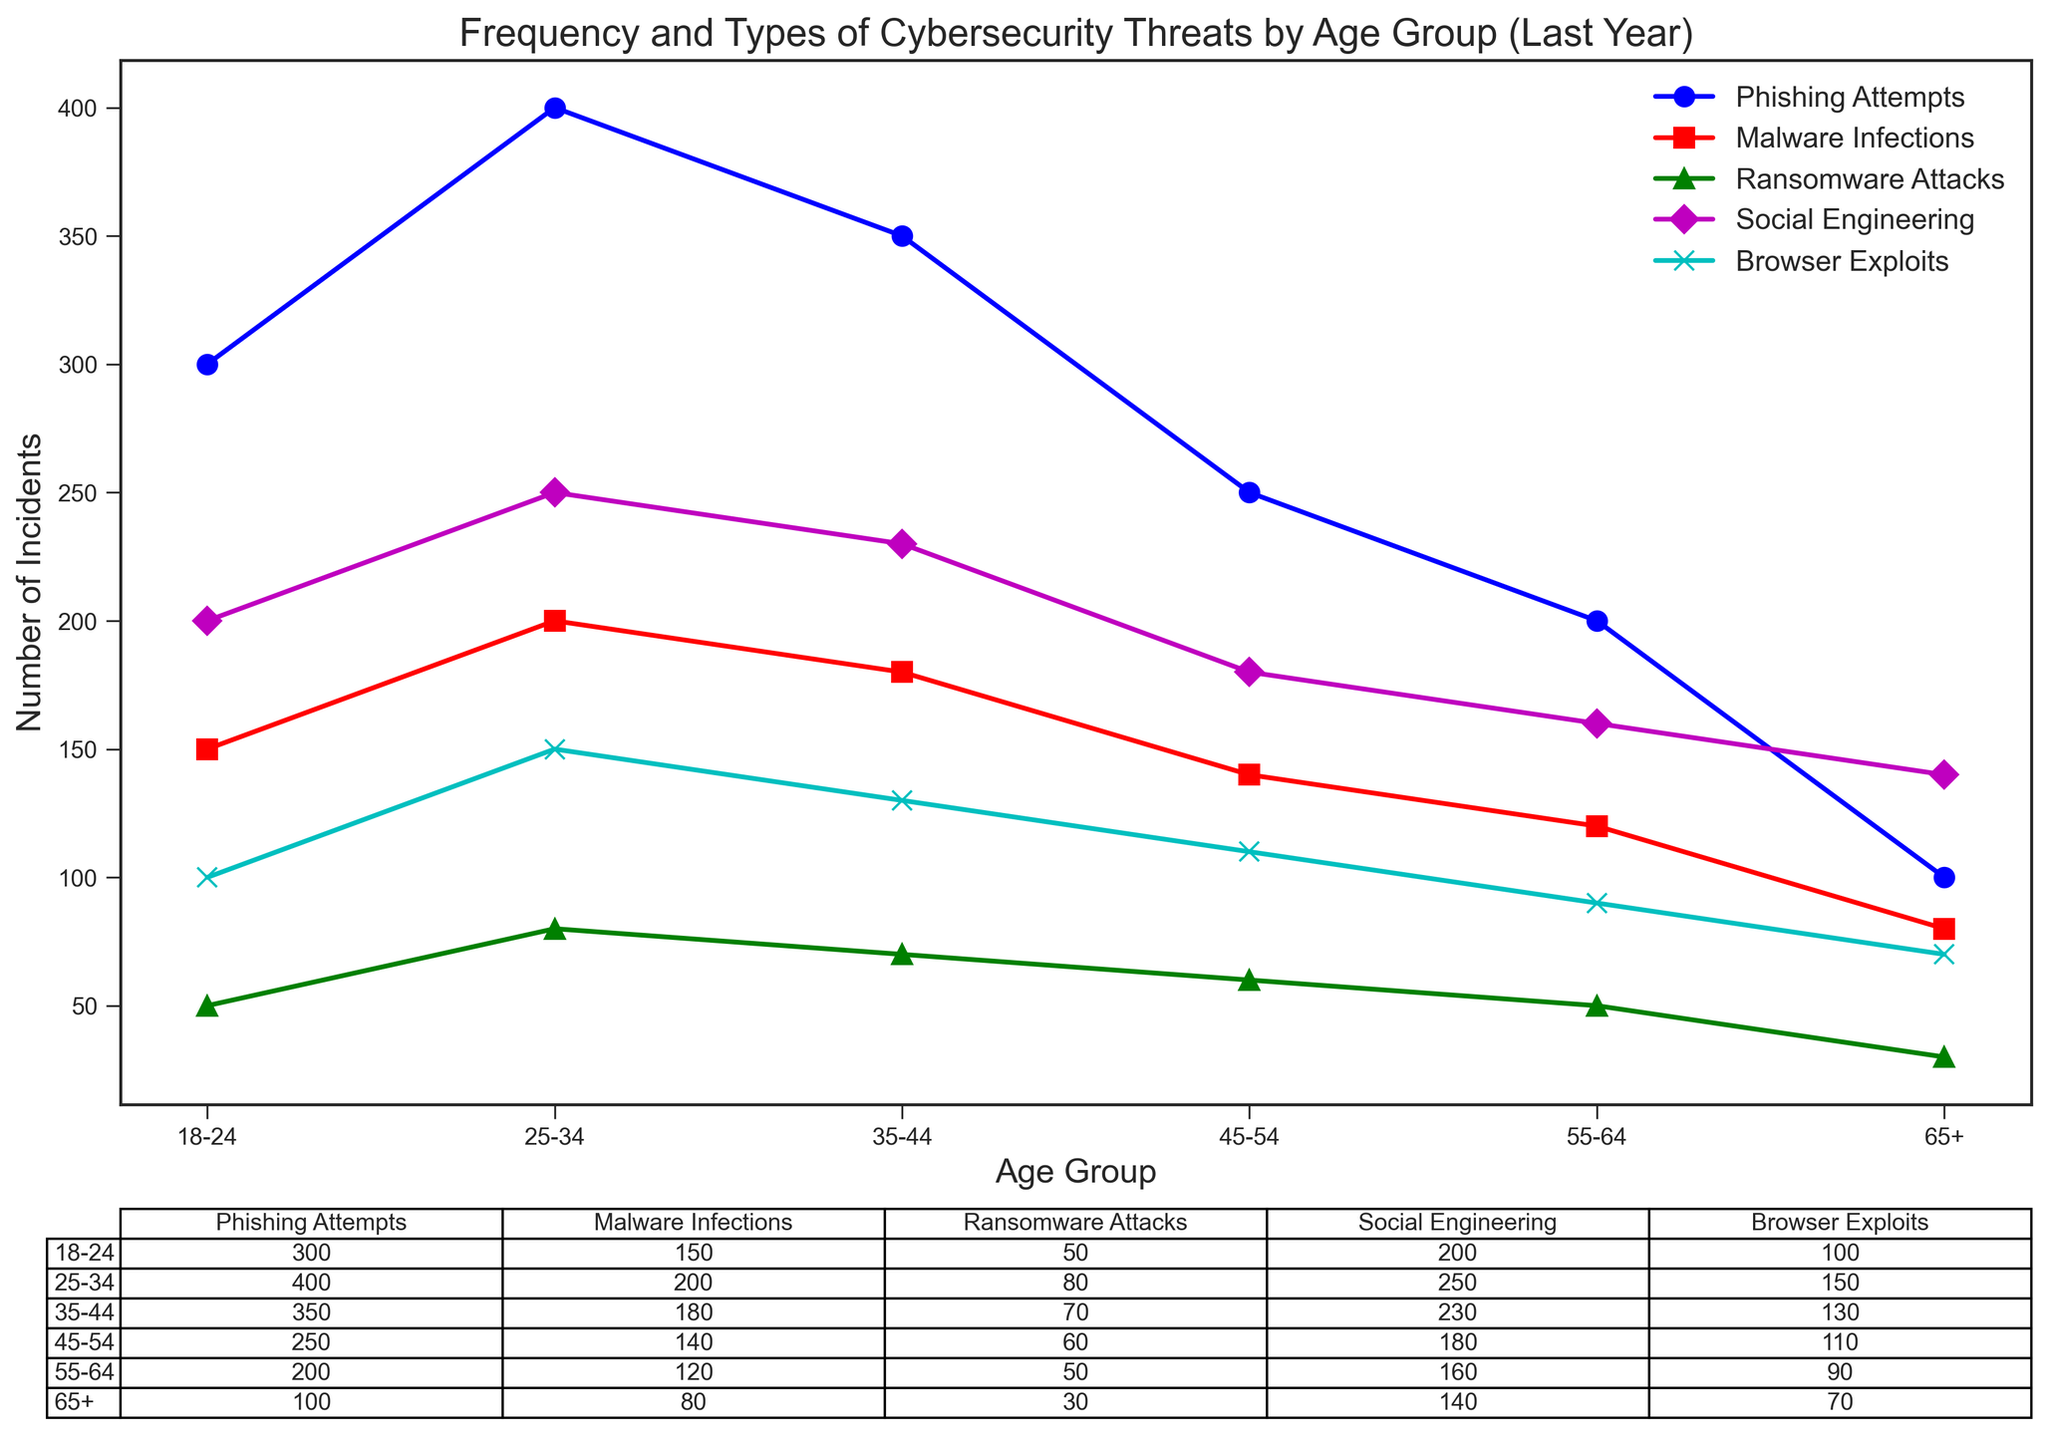What's the most frequent type of threat faced by the 18-24 age group? Looking at the plot, the highest point for the 18-24 age group is for Phishing Attempts, which is 300.
Answer: Phishing Attempts Which age group experienced the least number of Ransomware Attacks? By examining the line for Ransomware Attacks (green line with triangle markers), the lowest point is at the 65+ age group, which is 30.
Answer: 65+ How many more Social Engineering incidents were reported by the 25-34 age group compared to the 45-54 age group? The number of Social Engineering incidents for the 25-34 age group is 250 and for the 45-54 age group is 180. The difference is 250 - 180 = 70.
Answer: 70 Which age group faced the second highest number of Browser Exploits? The highest category Browser Exploits (cyan line with 'x' markers) belongs to the 25-34 age group with 150 incidents while the second highest is the 35-44 age group with 130 incidents.
Answer: 35-44 What is the sum of Malware Infections and Ransomware Attacks for the 35-44 age group? From the plot, Malware Infections for the 35-44 age group are 180 and Ransomware Attacks are 70. The sum is 180 + 70 = 250.
Answer: 250 Compare the Phishing Attempts between the 55-64 and 65+ age groups. Which age group had more incidents and by how much? Phishing Attempts for the 55-64 age group are 200 and for the 65+ age group is 100. The 55-64 age group had 200 - 100 = 100 more incidents.
Answer: 55-64; 100 What is the average number of Social Engineering threats faced across all age groups? Adding the Social Engineering threats (200 + 250 + 230 + 180 + 160 + 140) gives a total of 1160. Dividing by the number of age groups (6) gives 1160 / 6 = ~193.3.
Answer: ~193.3 Which type of threat consistently decreases with increasing age? By observing the lines, Phishing Attempts (blue line with circular markers) consistently decrease as age increases.
Answer: Phishing Attempts How many incidents of Browser Exploits were reported by the 18-24 age group? The plot shows the number of Browser Exploits for the 18-24 age group is 100.
Answer: 100 